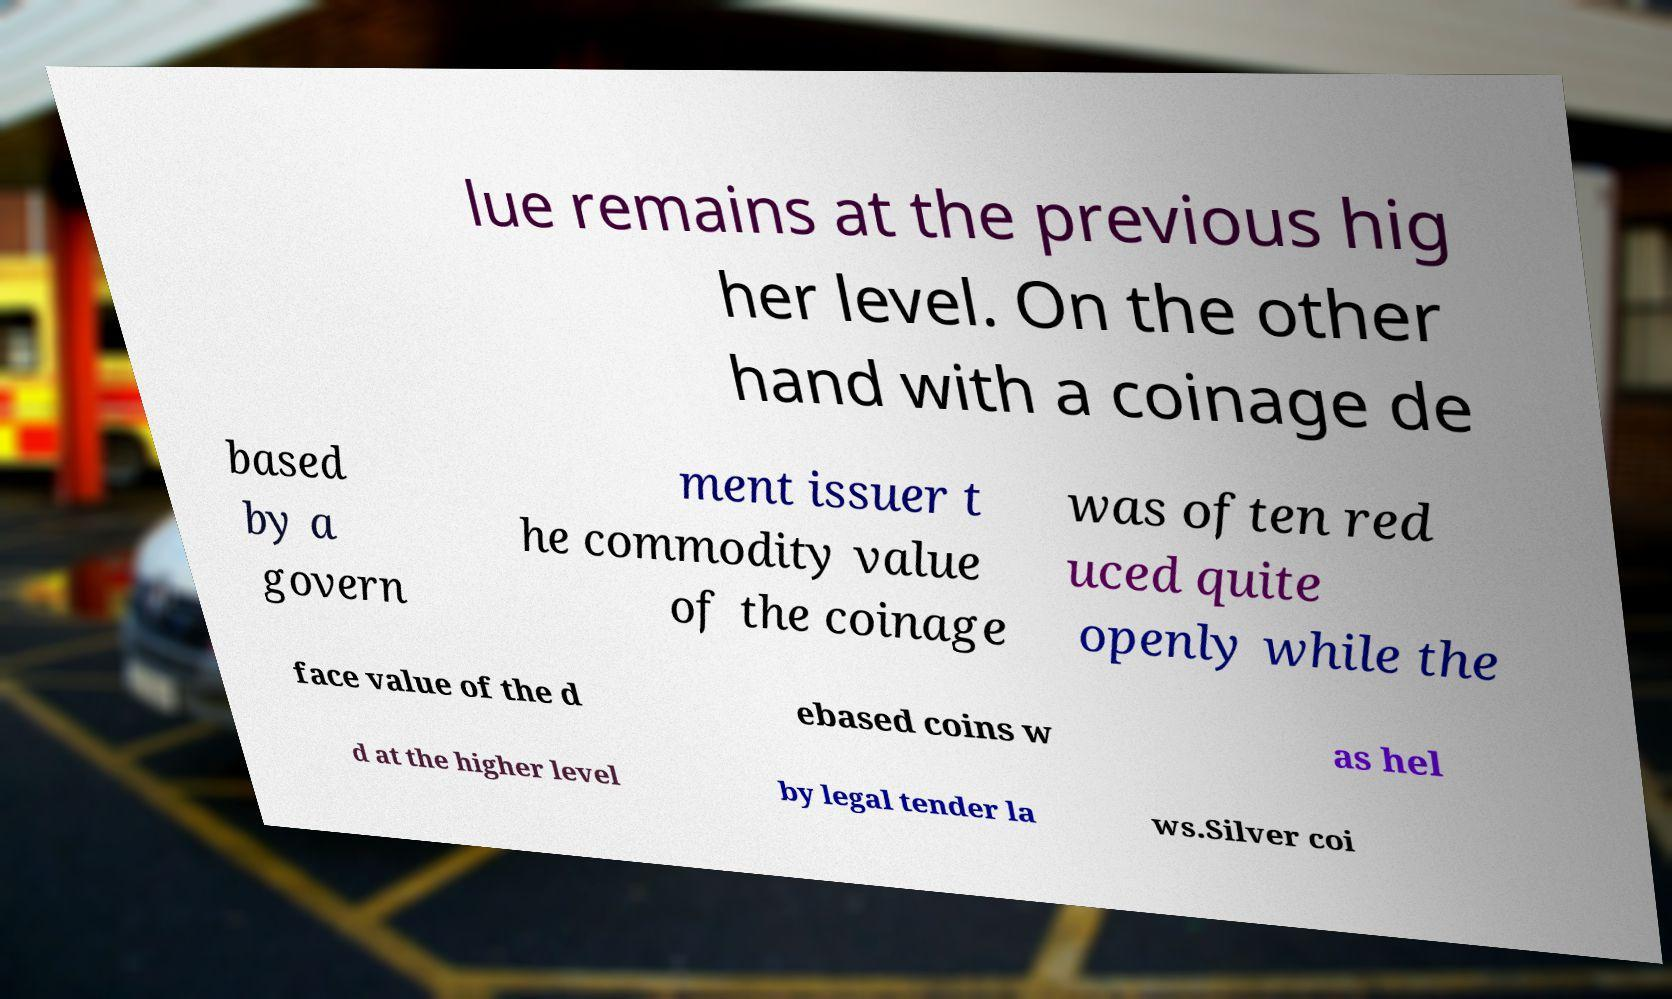Can you read and provide the text displayed in the image?This photo seems to have some interesting text. Can you extract and type it out for me? lue remains at the previous hig her level. On the other hand with a coinage de based by a govern ment issuer t he commodity value of the coinage was often red uced quite openly while the face value of the d ebased coins w as hel d at the higher level by legal tender la ws.Silver coi 